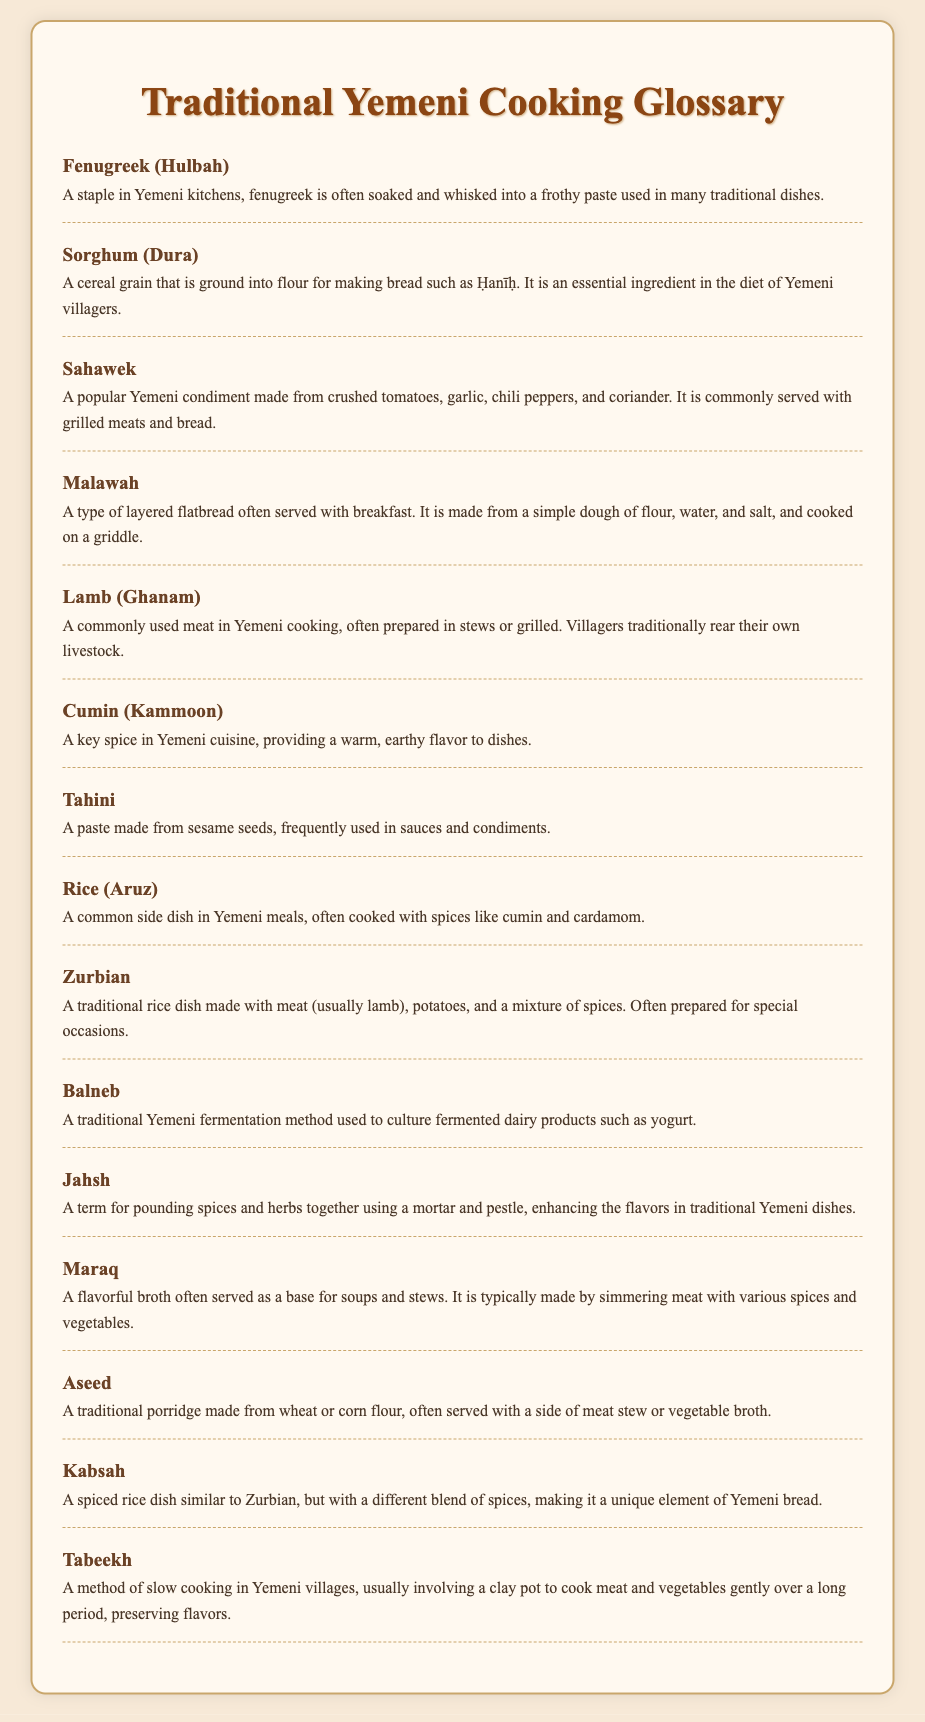What is a staple in Yemeni kitchens? The document states that fenugreek is a staple in Yemeni kitchens.
Answer: Fenugreek What is the traditional method of pounding spices called? The term for pounding spices and herbs together is "Jahsh."
Answer: Jahsh What type of meat is commonly used in Yemeni cooking? The document mentions that lamb is a commonly used meat.
Answer: Lamb What dish is made with meat, potatoes, and rice for special occasions? The document describes Zurbian as a traditional rice dish made with these ingredients.
Answer: Zurbian What type of bread is often served with breakfast? The glossary mentions that Malawah is a type of layered flatbread served with breakfast.
Answer: Malawah What is the paste made from sesame seeds used in sauces? The document refers to tahini as the paste made from sesame seeds.
Answer: Tahini What type of broth is typically made by simmering meat with spices and vegetables? The flavorful broth described in the document is called "Maraq."
Answer: Maraq Which grain is essential in the diet of Yemeni villagers? The document notes that sorghum is essential for making bread like Ḥanīḥ.
Answer: Sorghum 